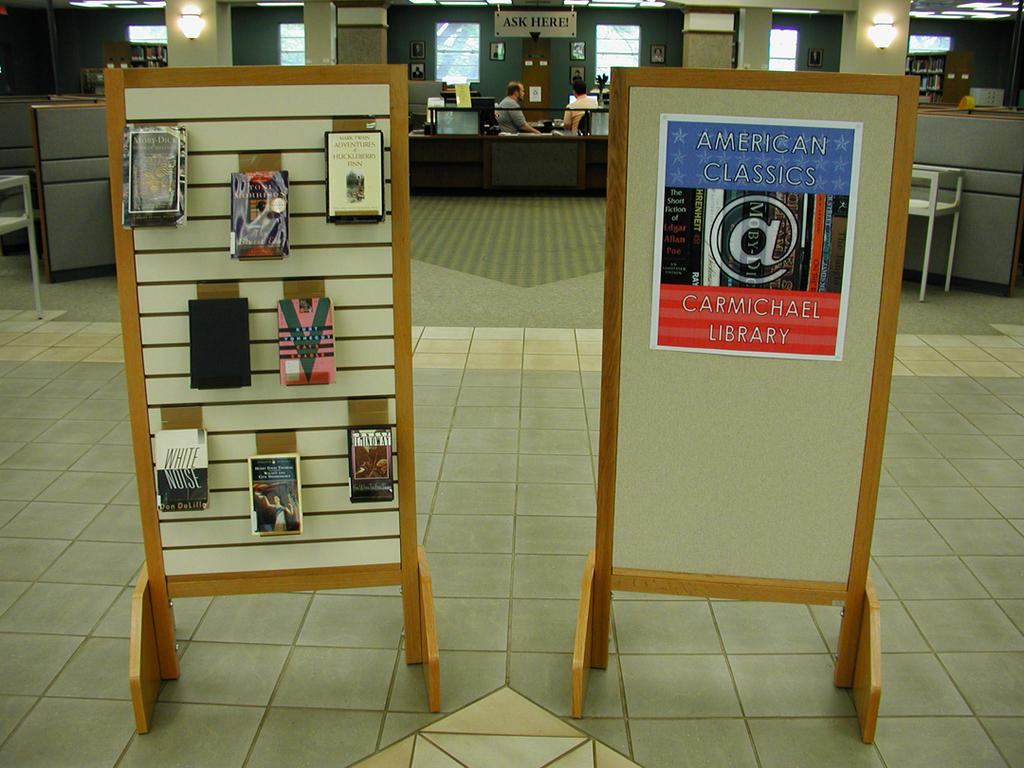How many people are in the image? There are persons in the image, but the exact number is not specified. What architectural features can be seen in the image? There are pillars in the image. What lighting elements are present in the image? There are lights in the image. What can be seen through the windows in the image? The presence of windows is mentioned, but what can be seen through them is not specified. Can you describe any other objects in the image? There are some unspecified objects in the image. Can you see a map in the image? There is no mention of a map in the image. 